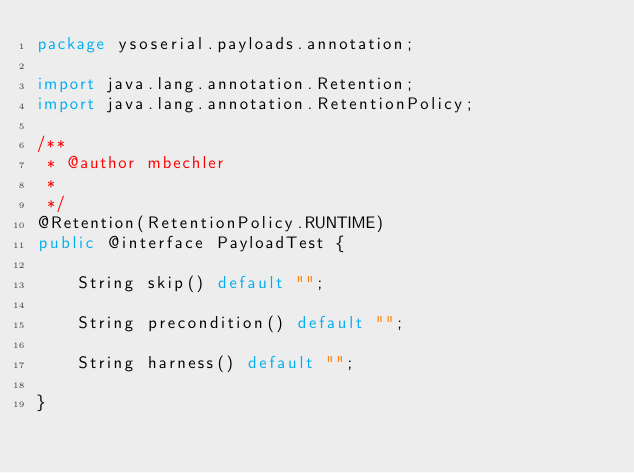Convert code to text. <code><loc_0><loc_0><loc_500><loc_500><_Java_>package ysoserial.payloads.annotation;

import java.lang.annotation.Retention;
import java.lang.annotation.RetentionPolicy;

/**
 * @author mbechler
 *
 */
@Retention(RetentionPolicy.RUNTIME)
public @interface PayloadTest {

    String skip() default "";
    
    String precondition() default "";
    
    String harness() default "";

}
</code> 